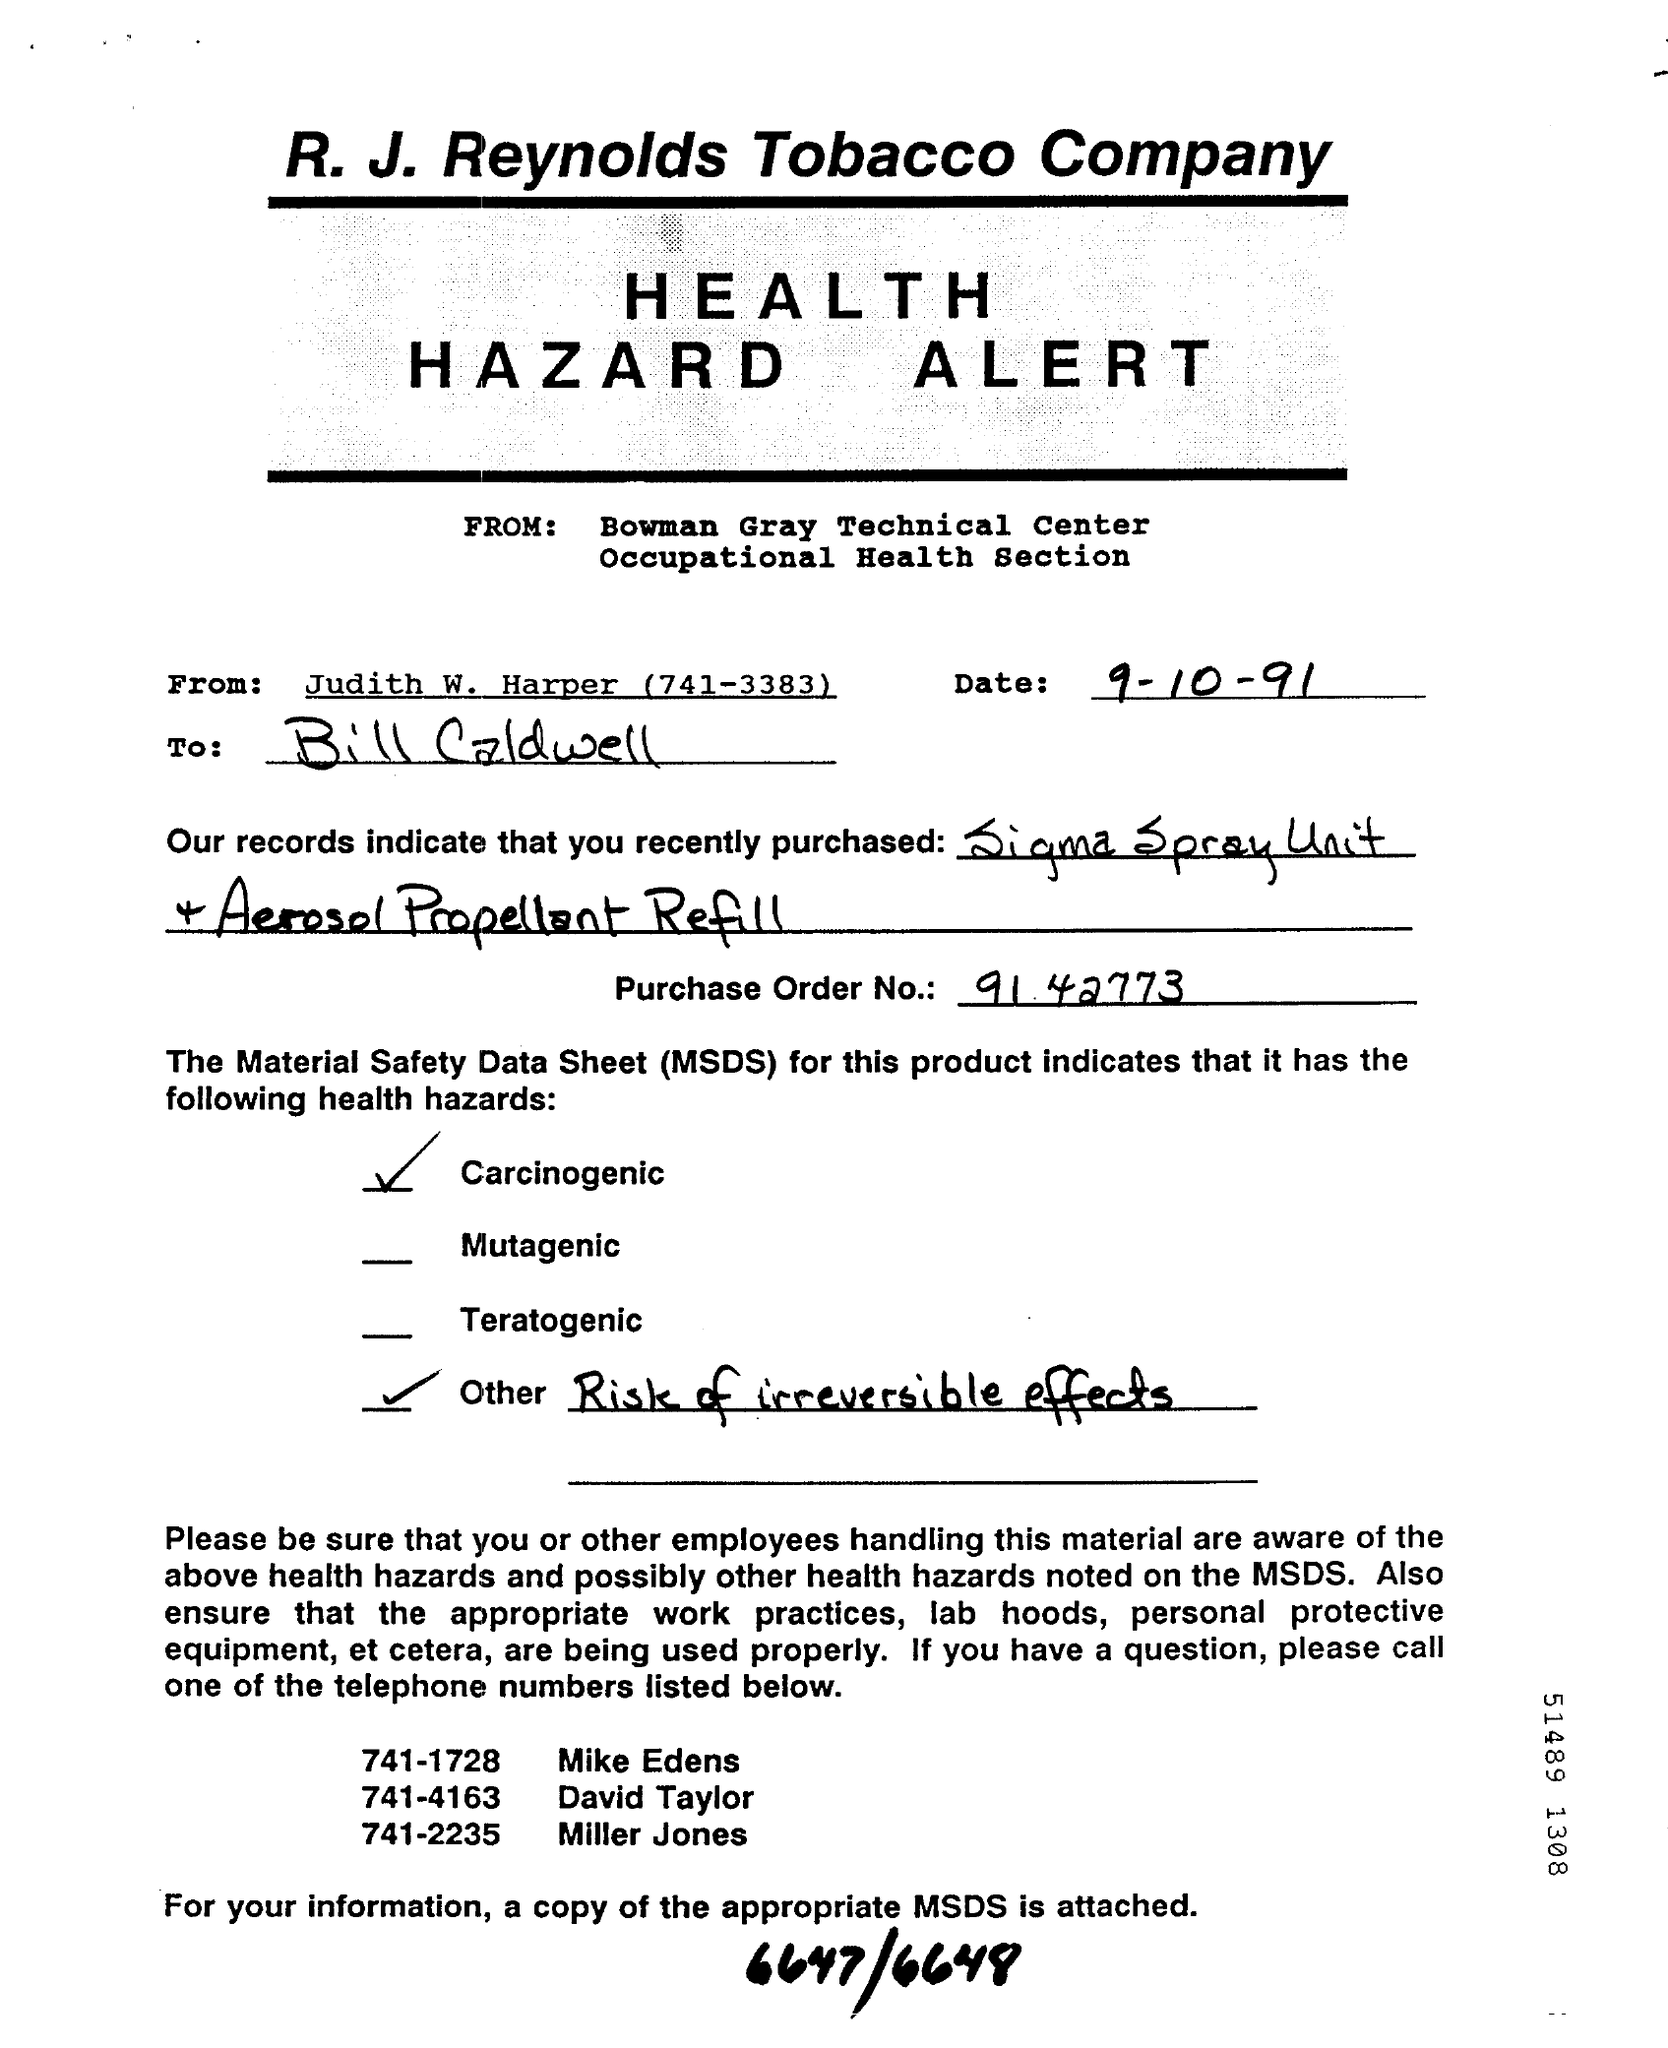Specify some key components in this picture. The date mentioned is 9-10-91. The telephone number of Mike Edens is 741-1728. The bill is sent from Judith W. Harper. The telephone number of Miller Jones is 741-2235. Bowman Gray is the name of the technical center. 